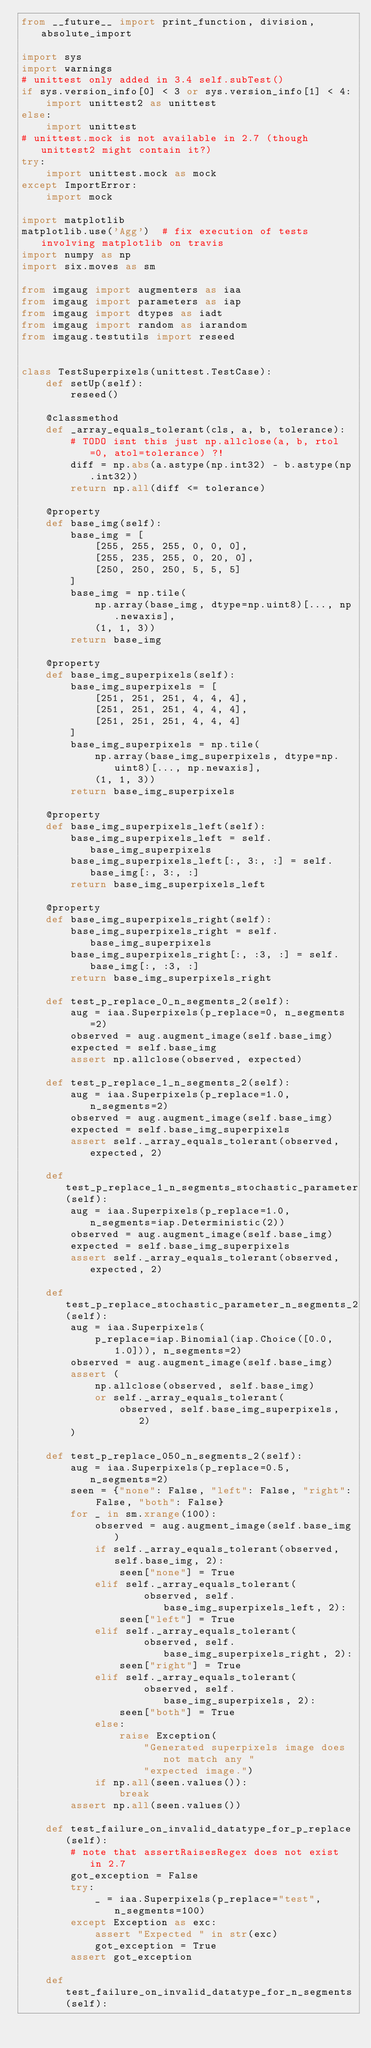<code> <loc_0><loc_0><loc_500><loc_500><_Python_>from __future__ import print_function, division, absolute_import

import sys
import warnings
# unittest only added in 3.4 self.subTest()
if sys.version_info[0] < 3 or sys.version_info[1] < 4:
    import unittest2 as unittest
else:
    import unittest
# unittest.mock is not available in 2.7 (though unittest2 might contain it?)
try:
    import unittest.mock as mock
except ImportError:
    import mock

import matplotlib
matplotlib.use('Agg')  # fix execution of tests involving matplotlib on travis
import numpy as np
import six.moves as sm

from imgaug import augmenters as iaa
from imgaug import parameters as iap
from imgaug import dtypes as iadt
from imgaug import random as iarandom
from imgaug.testutils import reseed


class TestSuperpixels(unittest.TestCase):
    def setUp(self):
        reseed()

    @classmethod
    def _array_equals_tolerant(cls, a, b, tolerance):
        # TODO isnt this just np.allclose(a, b, rtol=0, atol=tolerance) ?!
        diff = np.abs(a.astype(np.int32) - b.astype(np.int32))
        return np.all(diff <= tolerance)

    @property
    def base_img(self):
        base_img = [
            [255, 255, 255, 0, 0, 0],
            [255, 235, 255, 0, 20, 0],
            [250, 250, 250, 5, 5, 5]
        ]
        base_img = np.tile(
            np.array(base_img, dtype=np.uint8)[..., np.newaxis],
            (1, 1, 3))
        return base_img

    @property
    def base_img_superpixels(self):
        base_img_superpixels = [
            [251, 251, 251, 4, 4, 4],
            [251, 251, 251, 4, 4, 4],
            [251, 251, 251, 4, 4, 4]
        ]
        base_img_superpixels = np.tile(
            np.array(base_img_superpixels, dtype=np.uint8)[..., np.newaxis],
            (1, 1, 3))
        return base_img_superpixels

    @property
    def base_img_superpixels_left(self):
        base_img_superpixels_left = self.base_img_superpixels
        base_img_superpixels_left[:, 3:, :] = self.base_img[:, 3:, :]
        return base_img_superpixels_left

    @property
    def base_img_superpixels_right(self):
        base_img_superpixels_right = self.base_img_superpixels
        base_img_superpixels_right[:, :3, :] = self.base_img[:, :3, :]
        return base_img_superpixels_right

    def test_p_replace_0_n_segments_2(self):
        aug = iaa.Superpixels(p_replace=0, n_segments=2)
        observed = aug.augment_image(self.base_img)
        expected = self.base_img
        assert np.allclose(observed, expected)

    def test_p_replace_1_n_segments_2(self):
        aug = iaa.Superpixels(p_replace=1.0, n_segments=2)
        observed = aug.augment_image(self.base_img)
        expected = self.base_img_superpixels
        assert self._array_equals_tolerant(observed, expected, 2)

    def test_p_replace_1_n_segments_stochastic_parameter(self):
        aug = iaa.Superpixels(p_replace=1.0, n_segments=iap.Deterministic(2))
        observed = aug.augment_image(self.base_img)
        expected = self.base_img_superpixels
        assert self._array_equals_tolerant(observed, expected, 2)

    def test_p_replace_stochastic_parameter_n_segments_2(self):
        aug = iaa.Superpixels(
            p_replace=iap.Binomial(iap.Choice([0.0, 1.0])), n_segments=2)
        observed = aug.augment_image(self.base_img)
        assert (
            np.allclose(observed, self.base_img)
            or self._array_equals_tolerant(
                observed, self.base_img_superpixels, 2)
        )

    def test_p_replace_050_n_segments_2(self):
        aug = iaa.Superpixels(p_replace=0.5, n_segments=2)
        seen = {"none": False, "left": False, "right": False, "both": False}
        for _ in sm.xrange(100):
            observed = aug.augment_image(self.base_img)
            if self._array_equals_tolerant(observed, self.base_img, 2):
                seen["none"] = True
            elif self._array_equals_tolerant(
                    observed, self.base_img_superpixels_left, 2):
                seen["left"] = True
            elif self._array_equals_tolerant(
                    observed, self.base_img_superpixels_right, 2):
                seen["right"] = True
            elif self._array_equals_tolerant(
                    observed, self.base_img_superpixels, 2):
                seen["both"] = True
            else:
                raise Exception(
                    "Generated superpixels image does not match any "
                    "expected image.")
            if np.all(seen.values()):
                break
        assert np.all(seen.values())

    def test_failure_on_invalid_datatype_for_p_replace(self):
        # note that assertRaisesRegex does not exist in 2.7
        got_exception = False
        try:
            _ = iaa.Superpixels(p_replace="test", n_segments=100)
        except Exception as exc:
            assert "Expected " in str(exc)
            got_exception = True
        assert got_exception

    def test_failure_on_invalid_datatype_for_n_segments(self):</code> 